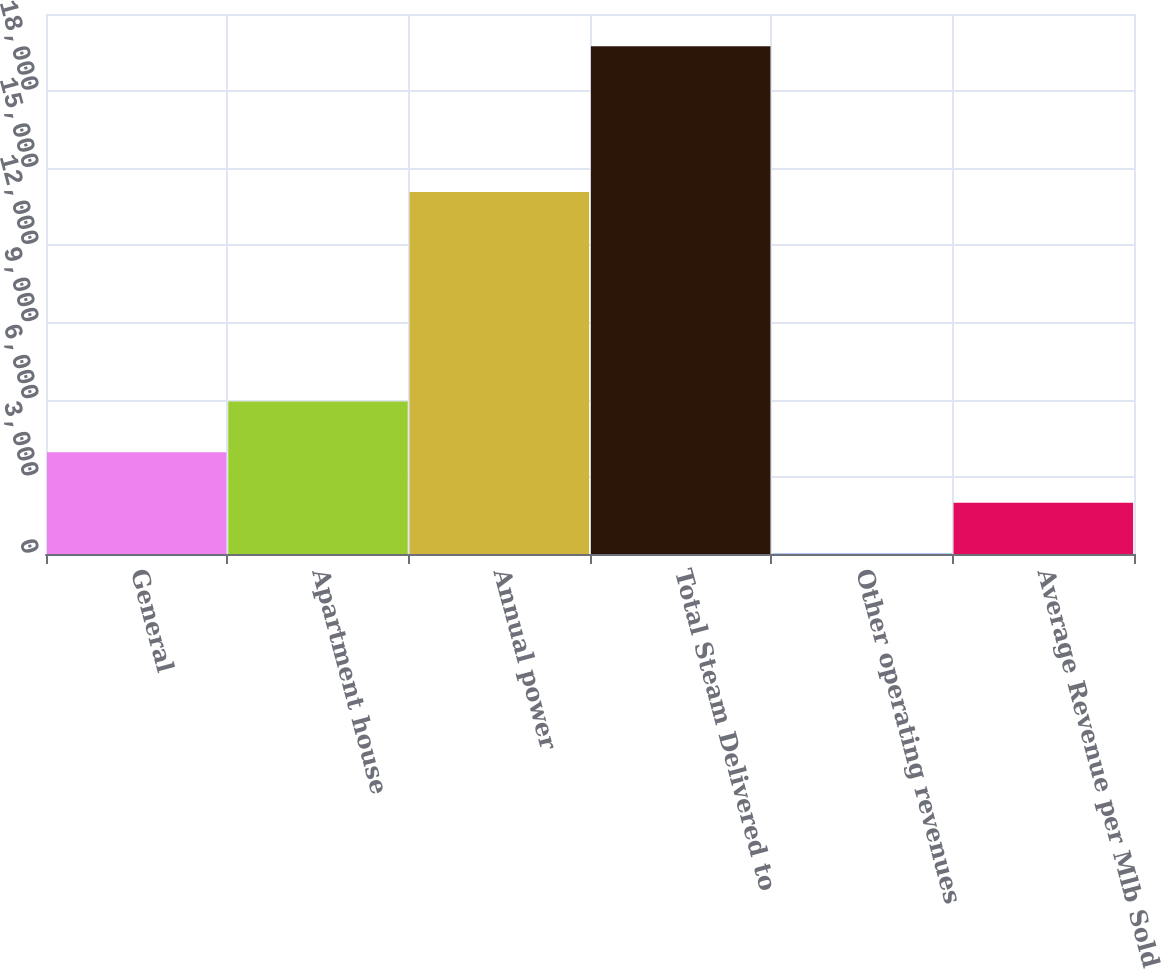Convert chart. <chart><loc_0><loc_0><loc_500><loc_500><bar_chart><fcel>General<fcel>Apartment house<fcel>Annual power<fcel>Total Steam Delivered to<fcel>Other operating revenues<fcel>Average Revenue per Mlb Sold<nl><fcel>3961<fcel>5933.5<fcel>14076<fcel>19741<fcel>16<fcel>1988.5<nl></chart> 